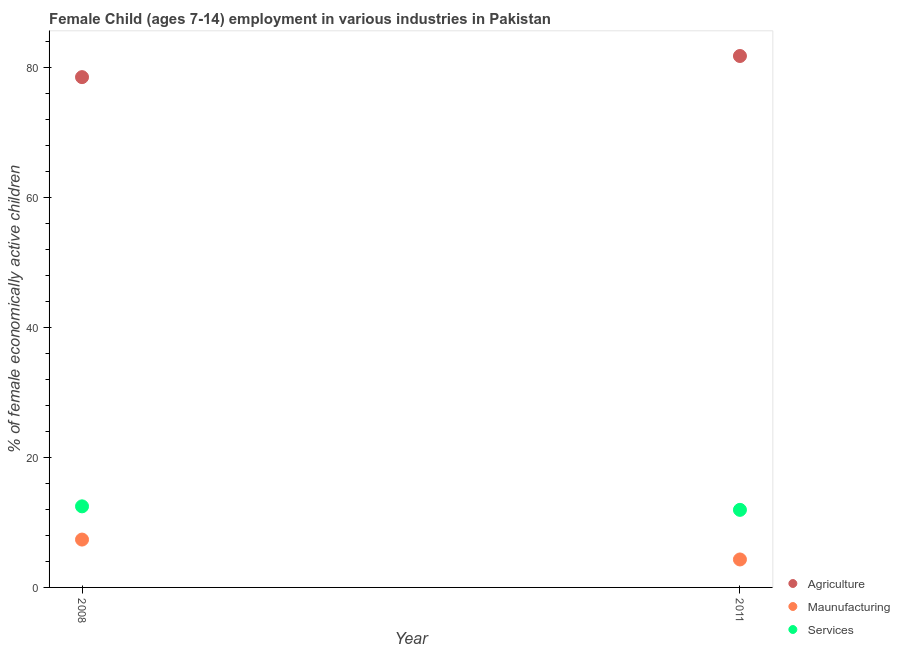What is the percentage of economically active children in agriculture in 2008?
Provide a short and direct response. 78.48. Across all years, what is the maximum percentage of economically active children in services?
Provide a succinct answer. 12.47. Across all years, what is the minimum percentage of economically active children in services?
Offer a very short reply. 11.93. In which year was the percentage of economically active children in manufacturing minimum?
Give a very brief answer. 2011. What is the total percentage of economically active children in agriculture in the graph?
Provide a succinct answer. 160.21. What is the difference between the percentage of economically active children in manufacturing in 2008 and that in 2011?
Make the answer very short. 3.06. What is the difference between the percentage of economically active children in manufacturing in 2011 and the percentage of economically active children in services in 2008?
Provide a short and direct response. -8.17. In the year 2011, what is the difference between the percentage of economically active children in agriculture and percentage of economically active children in services?
Your answer should be very brief. 69.8. What is the ratio of the percentage of economically active children in agriculture in 2008 to that in 2011?
Provide a short and direct response. 0.96. Does the percentage of economically active children in manufacturing monotonically increase over the years?
Keep it short and to the point. No. How many dotlines are there?
Offer a terse response. 3. How many years are there in the graph?
Provide a short and direct response. 2. Are the values on the major ticks of Y-axis written in scientific E-notation?
Ensure brevity in your answer.  No. Does the graph contain grids?
Make the answer very short. No. How many legend labels are there?
Offer a very short reply. 3. What is the title of the graph?
Provide a short and direct response. Female Child (ages 7-14) employment in various industries in Pakistan. Does "Secondary education" appear as one of the legend labels in the graph?
Offer a very short reply. No. What is the label or title of the X-axis?
Provide a succinct answer. Year. What is the label or title of the Y-axis?
Your answer should be very brief. % of female economically active children. What is the % of female economically active children of Agriculture in 2008?
Your answer should be very brief. 78.48. What is the % of female economically active children in Maunufacturing in 2008?
Give a very brief answer. 7.36. What is the % of female economically active children in Services in 2008?
Provide a short and direct response. 12.47. What is the % of female economically active children of Agriculture in 2011?
Make the answer very short. 81.73. What is the % of female economically active children of Maunufacturing in 2011?
Offer a very short reply. 4.3. What is the % of female economically active children of Services in 2011?
Provide a succinct answer. 11.93. Across all years, what is the maximum % of female economically active children in Agriculture?
Provide a succinct answer. 81.73. Across all years, what is the maximum % of female economically active children of Maunufacturing?
Provide a succinct answer. 7.36. Across all years, what is the maximum % of female economically active children in Services?
Provide a succinct answer. 12.47. Across all years, what is the minimum % of female economically active children in Agriculture?
Offer a very short reply. 78.48. Across all years, what is the minimum % of female economically active children in Maunufacturing?
Provide a short and direct response. 4.3. Across all years, what is the minimum % of female economically active children of Services?
Offer a terse response. 11.93. What is the total % of female economically active children in Agriculture in the graph?
Provide a succinct answer. 160.21. What is the total % of female economically active children of Maunufacturing in the graph?
Give a very brief answer. 11.66. What is the total % of female economically active children in Services in the graph?
Your answer should be very brief. 24.4. What is the difference between the % of female economically active children of Agriculture in 2008 and that in 2011?
Your response must be concise. -3.25. What is the difference between the % of female economically active children in Maunufacturing in 2008 and that in 2011?
Provide a short and direct response. 3.06. What is the difference between the % of female economically active children in Services in 2008 and that in 2011?
Offer a very short reply. 0.54. What is the difference between the % of female economically active children of Agriculture in 2008 and the % of female economically active children of Maunufacturing in 2011?
Your answer should be compact. 74.18. What is the difference between the % of female economically active children of Agriculture in 2008 and the % of female economically active children of Services in 2011?
Give a very brief answer. 66.55. What is the difference between the % of female economically active children in Maunufacturing in 2008 and the % of female economically active children in Services in 2011?
Offer a very short reply. -4.57. What is the average % of female economically active children in Agriculture per year?
Your answer should be very brief. 80.11. What is the average % of female economically active children in Maunufacturing per year?
Your response must be concise. 5.83. What is the average % of female economically active children in Services per year?
Keep it short and to the point. 12.2. In the year 2008, what is the difference between the % of female economically active children of Agriculture and % of female economically active children of Maunufacturing?
Offer a very short reply. 71.12. In the year 2008, what is the difference between the % of female economically active children in Agriculture and % of female economically active children in Services?
Your answer should be compact. 66.01. In the year 2008, what is the difference between the % of female economically active children of Maunufacturing and % of female economically active children of Services?
Make the answer very short. -5.11. In the year 2011, what is the difference between the % of female economically active children in Agriculture and % of female economically active children in Maunufacturing?
Offer a terse response. 77.43. In the year 2011, what is the difference between the % of female economically active children in Agriculture and % of female economically active children in Services?
Provide a succinct answer. 69.8. In the year 2011, what is the difference between the % of female economically active children in Maunufacturing and % of female economically active children in Services?
Your answer should be compact. -7.63. What is the ratio of the % of female economically active children of Agriculture in 2008 to that in 2011?
Give a very brief answer. 0.96. What is the ratio of the % of female economically active children of Maunufacturing in 2008 to that in 2011?
Offer a very short reply. 1.71. What is the ratio of the % of female economically active children in Services in 2008 to that in 2011?
Ensure brevity in your answer.  1.05. What is the difference between the highest and the second highest % of female economically active children of Maunufacturing?
Provide a succinct answer. 3.06. What is the difference between the highest and the second highest % of female economically active children in Services?
Offer a terse response. 0.54. What is the difference between the highest and the lowest % of female economically active children in Agriculture?
Give a very brief answer. 3.25. What is the difference between the highest and the lowest % of female economically active children in Maunufacturing?
Make the answer very short. 3.06. What is the difference between the highest and the lowest % of female economically active children of Services?
Provide a short and direct response. 0.54. 